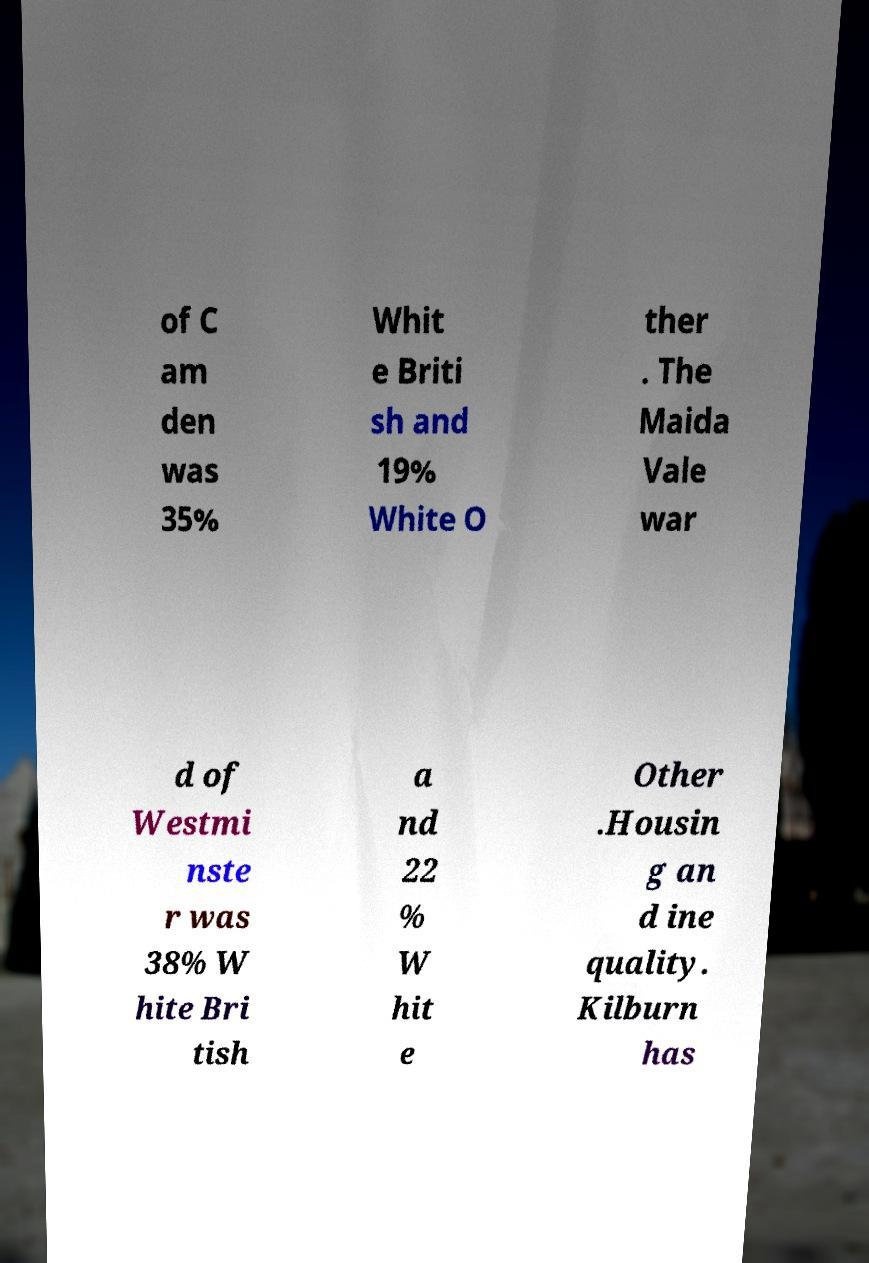Please read and relay the text visible in this image. What does it say? of C am den was 35% Whit e Briti sh and 19% White O ther . The Maida Vale war d of Westmi nste r was 38% W hite Bri tish a nd 22 % W hit e Other .Housin g an d ine quality. Kilburn has 